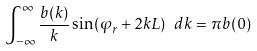Convert formula to latex. <formula><loc_0><loc_0><loc_500><loc_500>\int _ { - \infty } ^ { \infty } \frac { b ( k ) } { k } \sin ( \varphi _ { r } + 2 k L ) \ d k = \pi b ( 0 )</formula> 